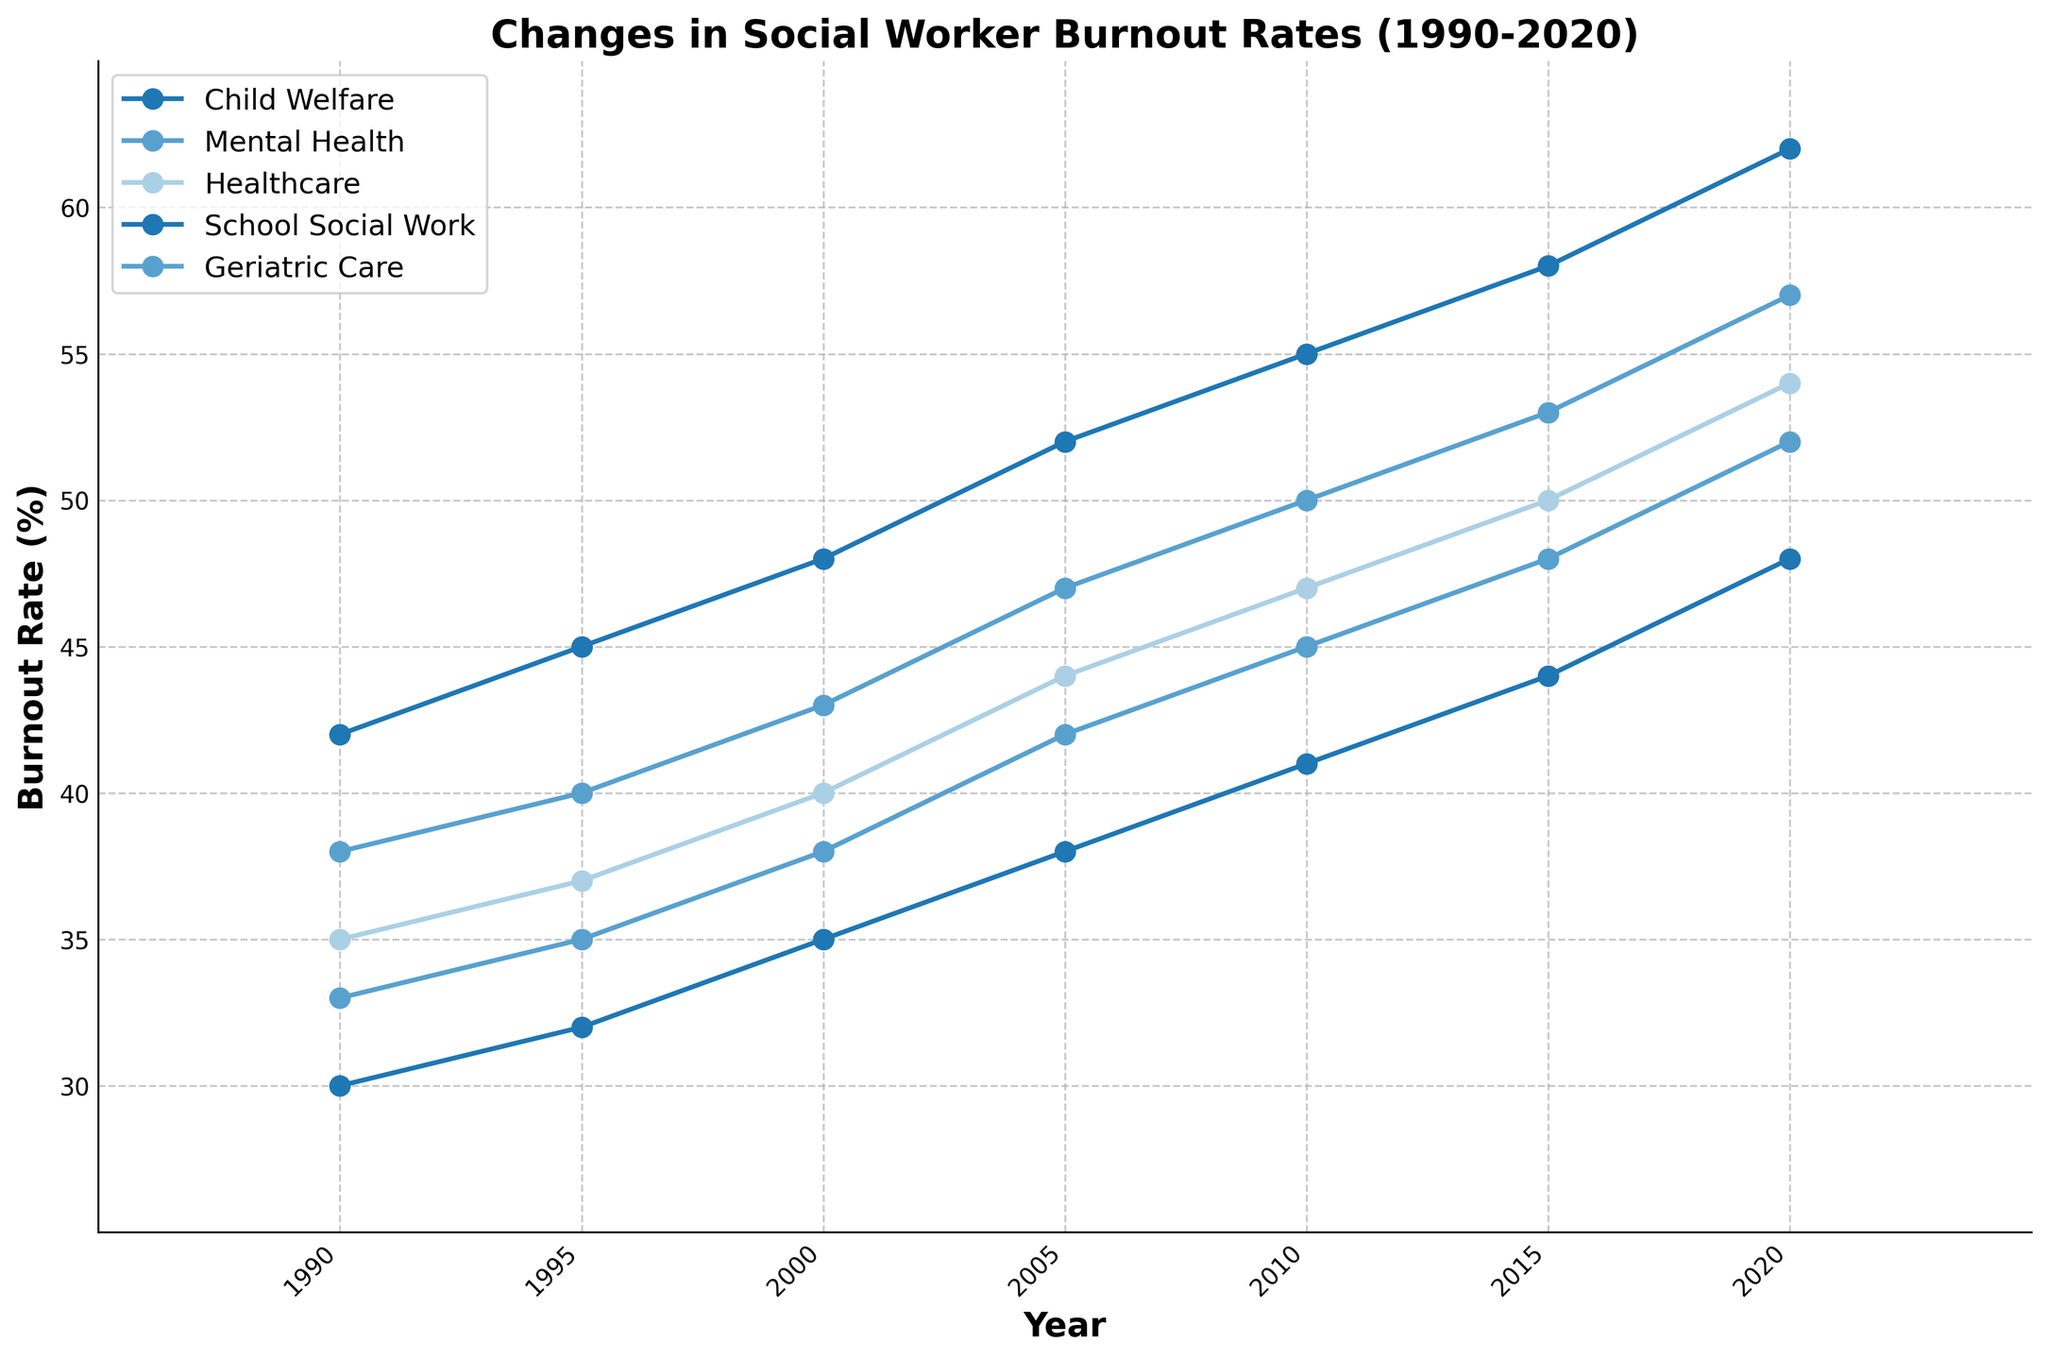Which specialization has the highest burnout rate in 2020? Look at the endpoints of the lines for each specialization in 2020 and identify which one is the highest. The burnout rates in 2020 are: Child Welfare (62%), Mental Health (57%), Healthcare (54%), School Social Work (48%), Geriatric Care (52%). Child Welfare has the highest burnout rate in 2020.
Answer: Child Welfare How much has the burnout rate changed for Mental Health from 1990 to 2020? Subtract the burnout rate for Mental Health in 1990 from the rate in 2020. The rates are: 57% (2020) and 38% (1990). The calculation is 57 - 38 = 19. Therefore, the burnout rate for Mental Health has changed by 19 percentage points.
Answer: 19 percentage points Which specialization had a higher burnout rate in 2010, Healthcare or Geriatric Care? Compare the burnout rates for Healthcare and Geriatric Care in 2010. The rates are: Healthcare (47%) and Geriatric Care (45%). Healthcare had a higher burnout rate in 2010.
Answer: Healthcare From 1990 to 2020, which specialization shows the most consistent increase in burnout rates? Observe the lines and trends of all specializations. Each specialization shows a steady increase, but Child Welfare shows a smooth and consistent incline without fluctuations, indicating a consistent increase.
Answer: Child Welfare What is the difference in burnout rates between child welfare and school social work in 1990 and 2020? Calculate the difference in burnout rates between Child Welfare and School Social Work for both 1990 and 2020. For 1990: 42% (Child Welfare) - 30% (School Social Work) = 12 percentage points. For 2020: 62% (Child Welfare) - 48% (School Social Work) = 14 percentage points. The differences are 12 and 14 percentage points respectively.
Answer: 12 percentage points, 14 percentage points Which specialization experienced the smallest increase in burnout rates from 1995 to 2005? Calculate the differences in burnout rates for all specializations between 1995 and 2005. Child Welfare: 52-45=7, Mental Health: 47-40=7, Healthcare: 44-37=7, School Social Work: 38-32=6, Geriatric Care: 42-35=7. School Social Work experienced the smallest increase of 6 percentage points.
Answer: School Social Work Rank the specializations from highest to lowest burnout rate in 2000. List the burnout rates for all specializations in 2000 and sort them. The rates are Child Welfare (48%), Mental Health (43%), Healthcare (40%), School Social Work (35%), Geriatric Care (38%). Ranking from highest to lowest: Child Welfare, Mental Health, Healthcare, Geriatric Care, School Social Work.
Answer: Child Welfare, Mental Health, Healthcare, Geriatric Care, School Social Work What's the average burnout rate of School Social Work across all the years? List all the burnout rates for School Social Work from 1990 to 2020, sum them up and then divide by the number of data points. The rates are: 30, 32, 35, 38, 41, 44, 48. The sum is 268. There are 7 data points. The average rate is 268 / 7 = approx. 38.29.
Answer: Approx. 38.29 How much did the burnout rate for Healthcare increase between 2010 and 2015? Subtract the 2010 burnout rate for Healthcare from the 2015 rate. The rates are 50% (2015) and 47% (2010). The increase is 50 - 47 = 3 percentage points.
Answer: 3 percentage points 